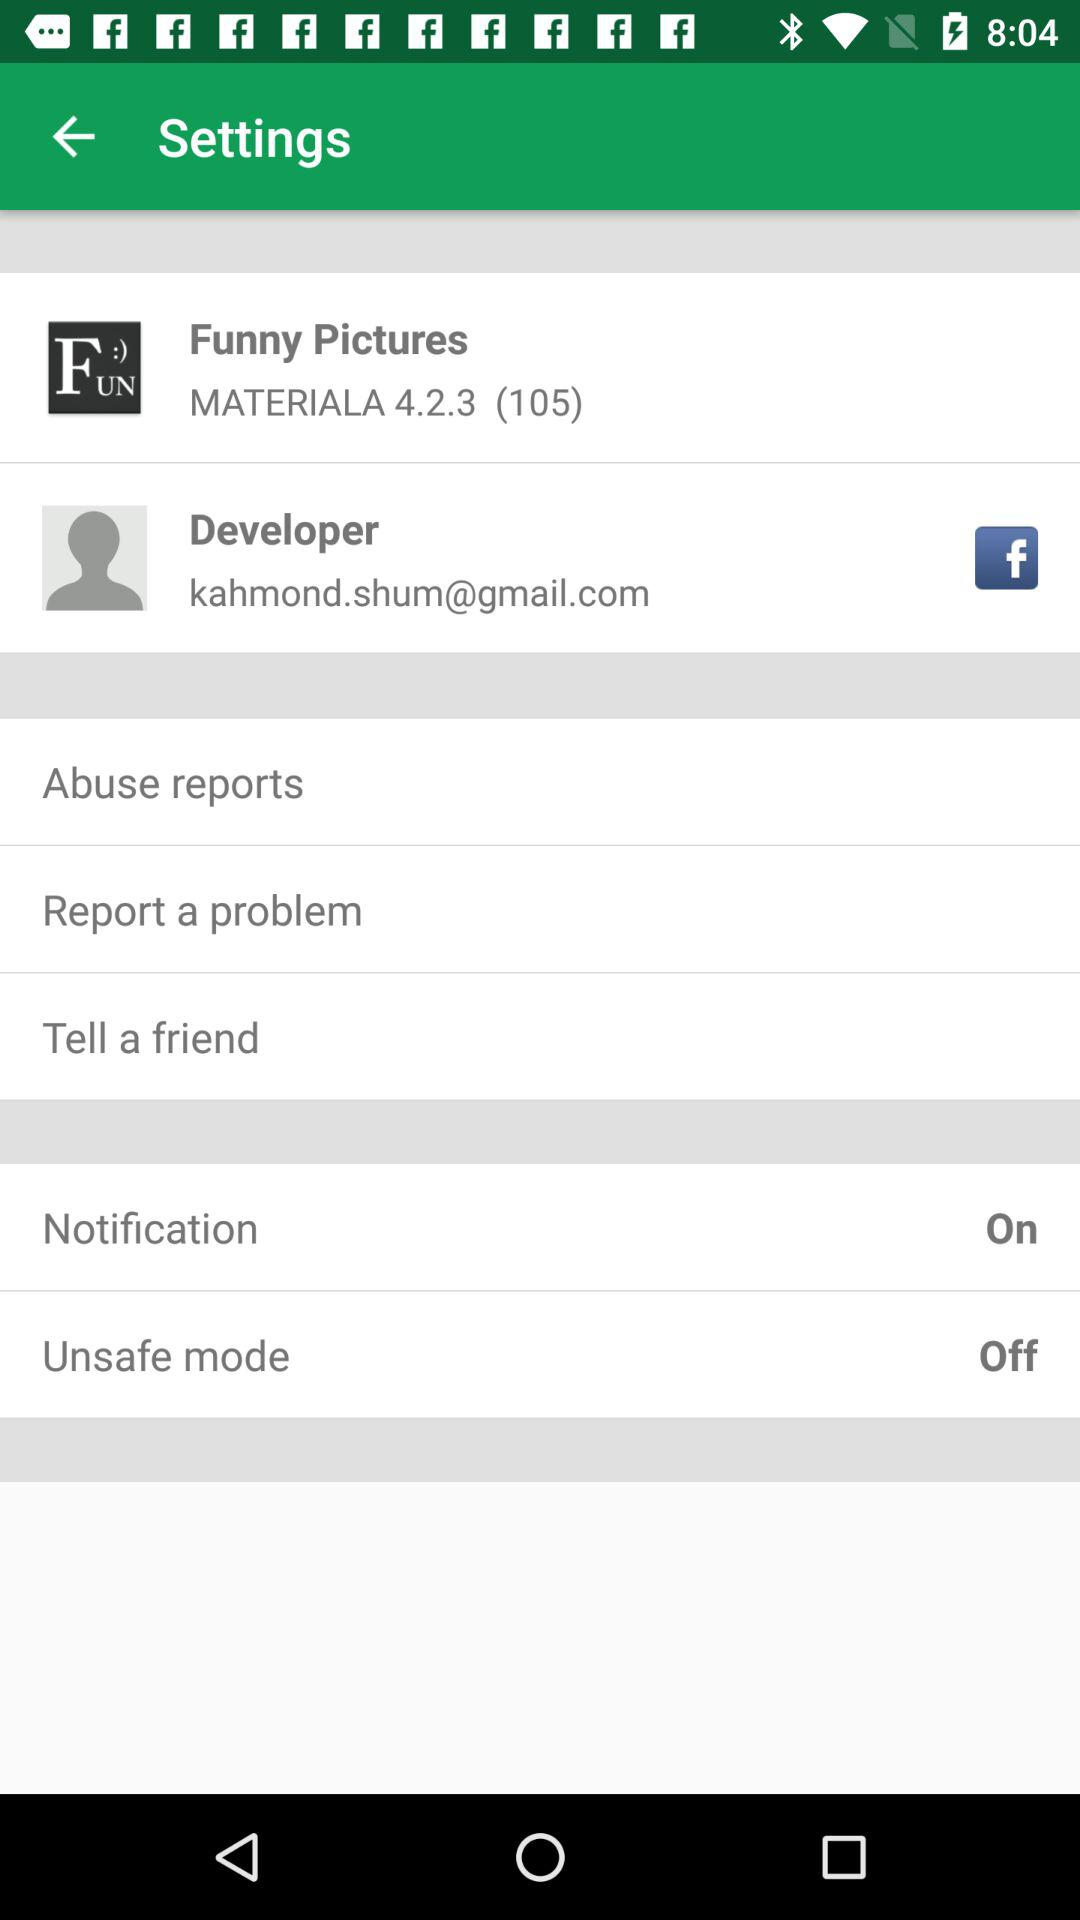What is the version code of "MATERIALA 4.2.3"? The version code is 105. 